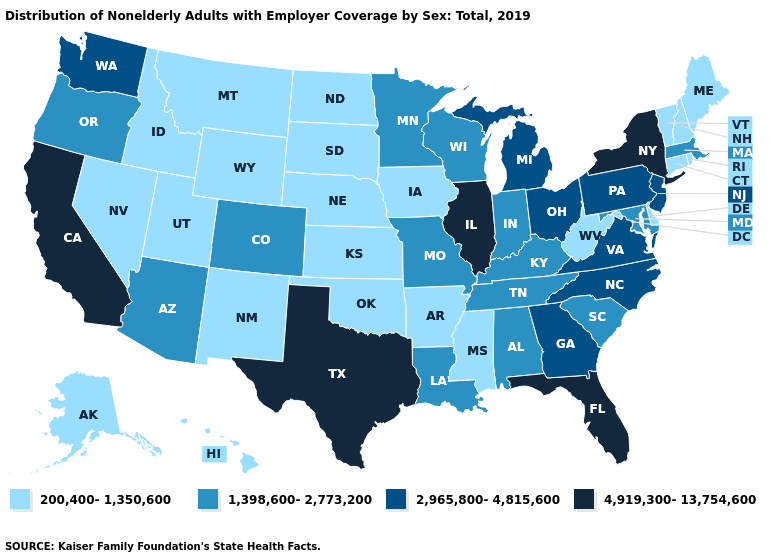Is the legend a continuous bar?
Quick response, please. No. What is the lowest value in the South?
Give a very brief answer. 200,400-1,350,600. Among the states that border Maryland , which have the highest value?
Be succinct. Pennsylvania, Virginia. Name the states that have a value in the range 200,400-1,350,600?
Short answer required. Alaska, Arkansas, Connecticut, Delaware, Hawaii, Idaho, Iowa, Kansas, Maine, Mississippi, Montana, Nebraska, Nevada, New Hampshire, New Mexico, North Dakota, Oklahoma, Rhode Island, South Dakota, Utah, Vermont, West Virginia, Wyoming. Among the states that border Michigan , does Ohio have the lowest value?
Keep it brief. No. Among the states that border Florida , does Georgia have the highest value?
Short answer required. Yes. Name the states that have a value in the range 200,400-1,350,600?
Write a very short answer. Alaska, Arkansas, Connecticut, Delaware, Hawaii, Idaho, Iowa, Kansas, Maine, Mississippi, Montana, Nebraska, Nevada, New Hampshire, New Mexico, North Dakota, Oklahoma, Rhode Island, South Dakota, Utah, Vermont, West Virginia, Wyoming. Does Vermont have the lowest value in the Northeast?
Be succinct. Yes. Name the states that have a value in the range 4,919,300-13,754,600?
Quick response, please. California, Florida, Illinois, New York, Texas. Is the legend a continuous bar?
Write a very short answer. No. What is the lowest value in the South?
Be succinct. 200,400-1,350,600. Does Vermont have the same value as Alaska?
Concise answer only. Yes. Does Florida have the highest value in the South?
Give a very brief answer. Yes. What is the value of South Carolina?
Short answer required. 1,398,600-2,773,200. Which states hav the highest value in the West?
Short answer required. California. 